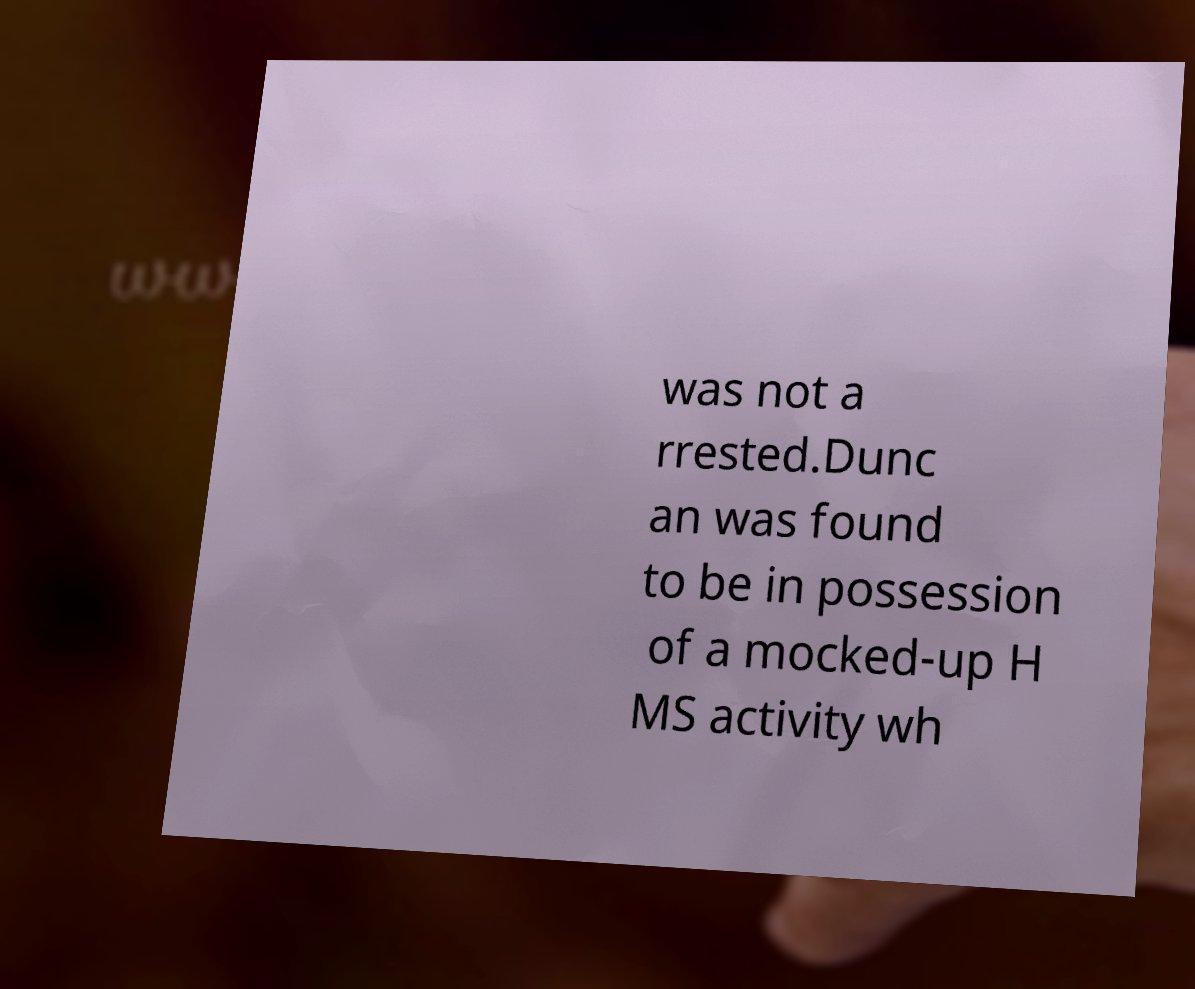There's text embedded in this image that I need extracted. Can you transcribe it verbatim? was not a rrested.Dunc an was found to be in possession of a mocked-up H MS activity wh 